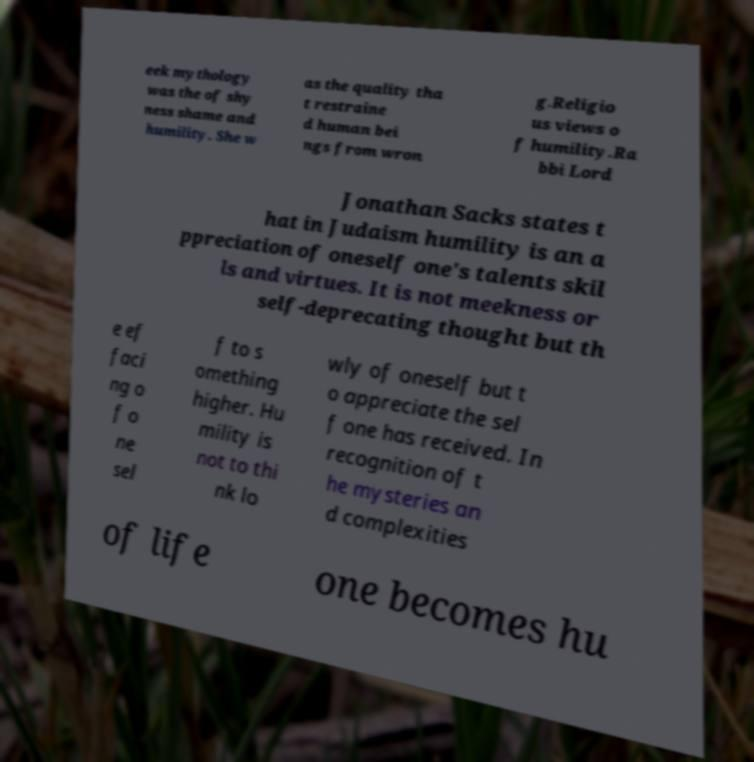Could you extract and type out the text from this image? eek mythology was the of shy ness shame and humility. She w as the quality tha t restraine d human bei ngs from wron g.Religio us views o f humility.Ra bbi Lord Jonathan Sacks states t hat in Judaism humility is an a ppreciation of oneself one's talents skil ls and virtues. It is not meekness or self-deprecating thought but th e ef faci ng o f o ne sel f to s omething higher. Hu mility is not to thi nk lo wly of oneself but t o appreciate the sel f one has received. In recognition of t he mysteries an d complexities of life one becomes hu 